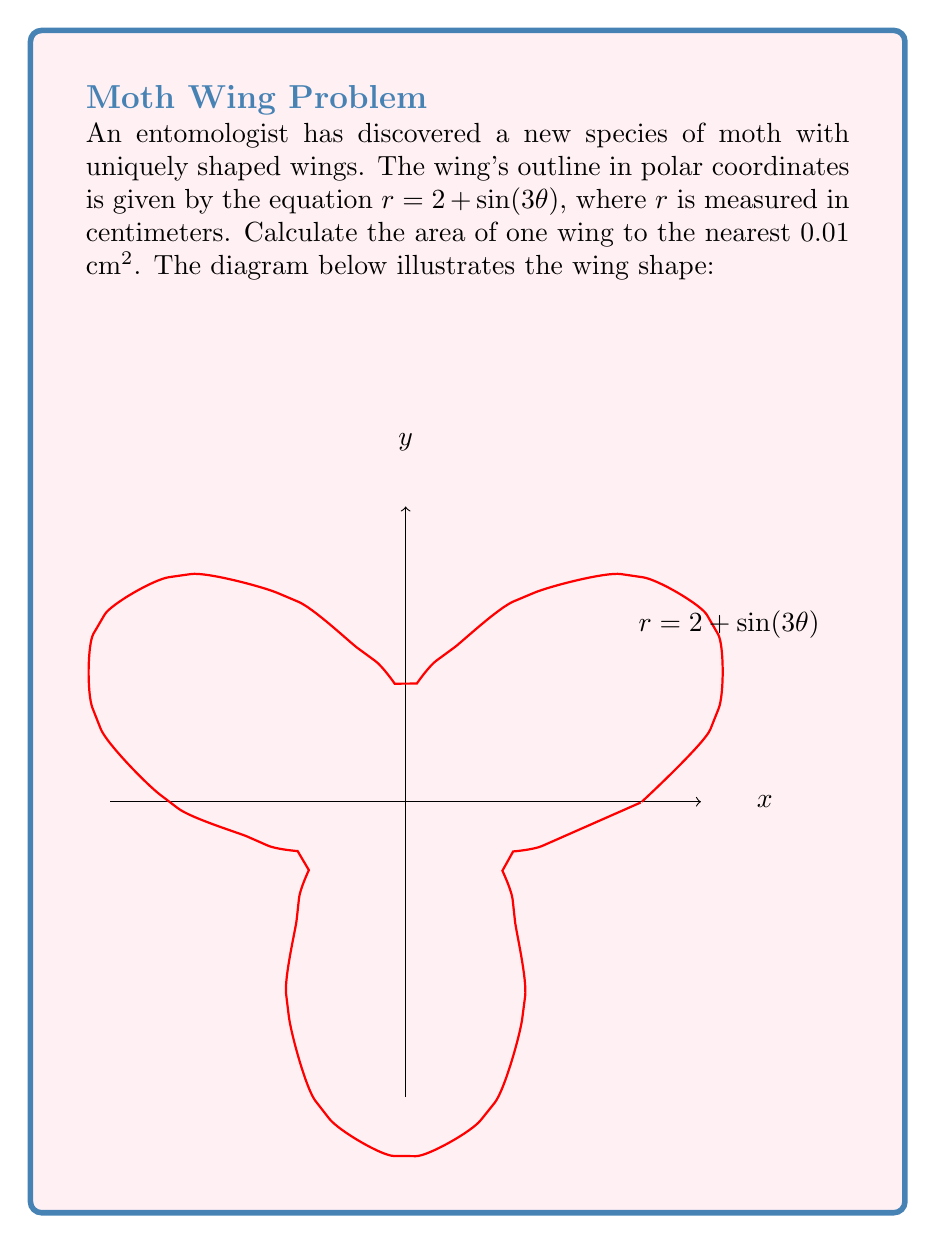Solve this math problem. To calculate the area of the wing using polar coordinates, we need to use the formula:

$$ A = \frac{1}{2} \int_{0}^{2\pi} r^2(\theta) d\theta $$

Where $r(\theta) = 2 + \sin(3\theta)$

Step 1: Square the function $r(\theta)$
$$ r^2(\theta) = (2 + \sin(3\theta))^2 = 4 + 4\sin(3\theta) + \sin^2(3\theta) $$

Step 2: Set up the integral
$$ A = \frac{1}{2} \int_{0}^{2\pi} (4 + 4\sin(3\theta) + \sin^2(3\theta)) d\theta $$

Step 3: Integrate each term
- $\int_{0}^{2\pi} 4 d\theta = 4\theta \Big|_{0}^{2\pi} = 8\pi$
- $\int_{0}^{2\pi} 4\sin(3\theta) d\theta = -\frac{4}{3}\cos(3\theta) \Big|_{0}^{2\pi} = 0$
- $\int_{0}^{2\pi} \sin^2(3\theta) d\theta = \int_{0}^{2\pi} \frac{1 - \cos(6\theta)}{2} d\theta = \frac{\theta}{2} - \frac{\sin(6\theta)}{12} \Big|_{0}^{2\pi} = \pi$

Step 4: Sum the results and multiply by $\frac{1}{2}$
$$ A = \frac{1}{2}(8\pi + 0 + \pi) = \frac{9\pi}{2} \approx 14.1372 \text{ cm}^2 $$

Step 5: Round to the nearest 0.01 cm²
$$ A \approx 14.14 \text{ cm}^2 $$
Answer: $14.14 \text{ cm}^2$ 